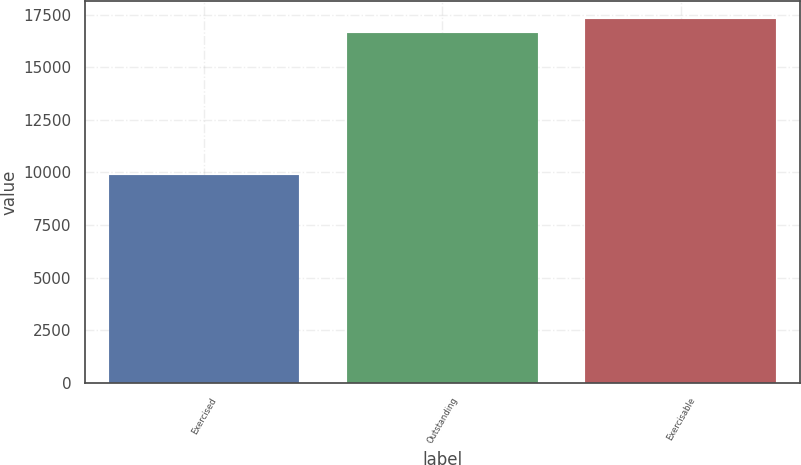Convert chart. <chart><loc_0><loc_0><loc_500><loc_500><bar_chart><fcel>Exercised<fcel>Outstanding<fcel>Exercisable<nl><fcel>9890<fcel>16605<fcel>17276.5<nl></chart> 